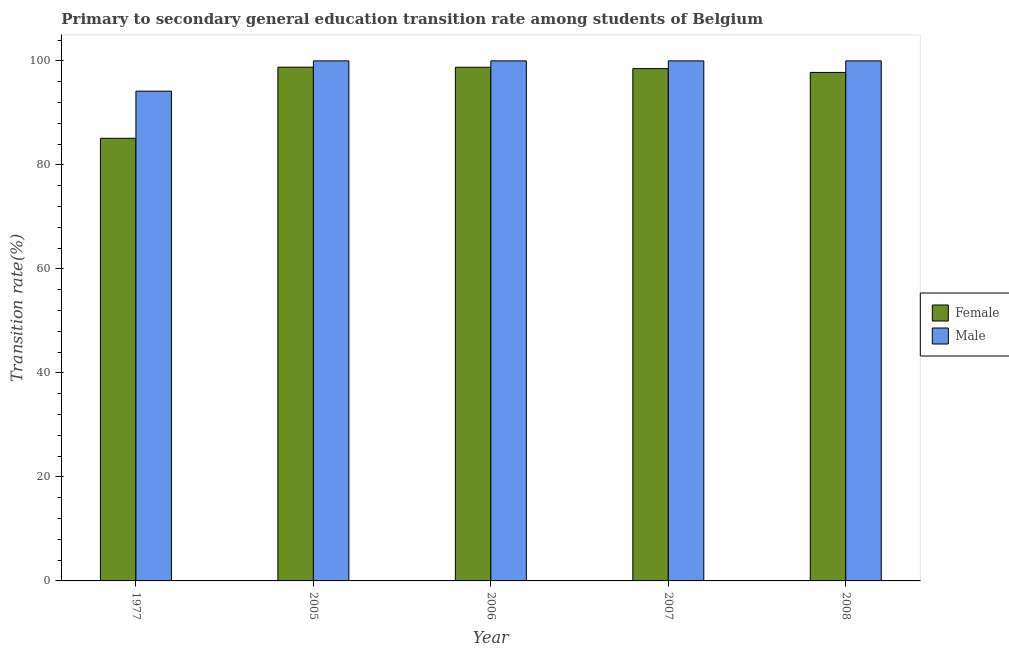How many different coloured bars are there?
Give a very brief answer. 2. Are the number of bars per tick equal to the number of legend labels?
Offer a very short reply. Yes. How many bars are there on the 3rd tick from the left?
Your answer should be compact. 2. In how many cases, is the number of bars for a given year not equal to the number of legend labels?
Give a very brief answer. 0. What is the transition rate among male students in 1977?
Offer a very short reply. 94.18. Across all years, what is the maximum transition rate among male students?
Keep it short and to the point. 100. Across all years, what is the minimum transition rate among male students?
Your answer should be very brief. 94.18. In which year was the transition rate among female students maximum?
Ensure brevity in your answer.  2005. What is the total transition rate among male students in the graph?
Offer a very short reply. 494.18. What is the difference between the transition rate among female students in 2005 and that in 2007?
Keep it short and to the point. 0.27. What is the difference between the transition rate among male students in 2008 and the transition rate among female students in 1977?
Provide a succinct answer. 5.82. What is the average transition rate among female students per year?
Give a very brief answer. 95.79. In the year 2006, what is the difference between the transition rate among male students and transition rate among female students?
Your response must be concise. 0. What is the ratio of the transition rate among female students in 2007 to that in 2008?
Keep it short and to the point. 1.01. Is the transition rate among female students in 2006 less than that in 2008?
Ensure brevity in your answer.  No. What is the difference between the highest and the second highest transition rate among female students?
Provide a succinct answer. 0.02. What is the difference between the highest and the lowest transition rate among male students?
Offer a very short reply. 5.82. In how many years, is the transition rate among female students greater than the average transition rate among female students taken over all years?
Your answer should be very brief. 4. How many bars are there?
Offer a very short reply. 10. How many years are there in the graph?
Provide a succinct answer. 5. Does the graph contain grids?
Offer a very short reply. No. How many legend labels are there?
Your response must be concise. 2. How are the legend labels stacked?
Provide a succinct answer. Vertical. What is the title of the graph?
Offer a terse response. Primary to secondary general education transition rate among students of Belgium. What is the label or title of the X-axis?
Provide a short and direct response. Year. What is the label or title of the Y-axis?
Your answer should be compact. Transition rate(%). What is the Transition rate(%) of Female in 1977?
Your answer should be very brief. 85.11. What is the Transition rate(%) of Male in 1977?
Provide a short and direct response. 94.18. What is the Transition rate(%) in Female in 2005?
Provide a succinct answer. 98.79. What is the Transition rate(%) of Female in 2006?
Your answer should be very brief. 98.77. What is the Transition rate(%) in Male in 2006?
Your answer should be compact. 100. What is the Transition rate(%) in Female in 2007?
Offer a very short reply. 98.52. What is the Transition rate(%) in Female in 2008?
Ensure brevity in your answer.  97.78. What is the Transition rate(%) in Male in 2008?
Your response must be concise. 100. Across all years, what is the maximum Transition rate(%) of Female?
Provide a short and direct response. 98.79. Across all years, what is the maximum Transition rate(%) in Male?
Provide a short and direct response. 100. Across all years, what is the minimum Transition rate(%) in Female?
Make the answer very short. 85.11. Across all years, what is the minimum Transition rate(%) in Male?
Offer a very short reply. 94.18. What is the total Transition rate(%) of Female in the graph?
Ensure brevity in your answer.  478.96. What is the total Transition rate(%) in Male in the graph?
Ensure brevity in your answer.  494.18. What is the difference between the Transition rate(%) in Female in 1977 and that in 2005?
Your response must be concise. -13.67. What is the difference between the Transition rate(%) in Male in 1977 and that in 2005?
Ensure brevity in your answer.  -5.82. What is the difference between the Transition rate(%) in Female in 1977 and that in 2006?
Your answer should be very brief. -13.65. What is the difference between the Transition rate(%) of Male in 1977 and that in 2006?
Offer a very short reply. -5.82. What is the difference between the Transition rate(%) in Female in 1977 and that in 2007?
Your answer should be compact. -13.4. What is the difference between the Transition rate(%) in Male in 1977 and that in 2007?
Offer a very short reply. -5.82. What is the difference between the Transition rate(%) of Female in 1977 and that in 2008?
Offer a very short reply. -12.66. What is the difference between the Transition rate(%) of Male in 1977 and that in 2008?
Your response must be concise. -5.82. What is the difference between the Transition rate(%) in Female in 2005 and that in 2006?
Provide a short and direct response. 0.02. What is the difference between the Transition rate(%) in Male in 2005 and that in 2006?
Your answer should be compact. 0. What is the difference between the Transition rate(%) of Female in 2005 and that in 2007?
Offer a very short reply. 0.27. What is the difference between the Transition rate(%) in Male in 2005 and that in 2007?
Provide a short and direct response. 0. What is the difference between the Transition rate(%) in Female in 2005 and that in 2008?
Your answer should be compact. 1.01. What is the difference between the Transition rate(%) of Male in 2005 and that in 2008?
Offer a terse response. 0. What is the difference between the Transition rate(%) of Female in 2006 and that in 2007?
Offer a very short reply. 0.25. What is the difference between the Transition rate(%) of Female in 2006 and that in 2008?
Keep it short and to the point. 0.99. What is the difference between the Transition rate(%) in Female in 2007 and that in 2008?
Offer a terse response. 0.74. What is the difference between the Transition rate(%) in Female in 1977 and the Transition rate(%) in Male in 2005?
Give a very brief answer. -14.89. What is the difference between the Transition rate(%) of Female in 1977 and the Transition rate(%) of Male in 2006?
Provide a short and direct response. -14.89. What is the difference between the Transition rate(%) in Female in 1977 and the Transition rate(%) in Male in 2007?
Make the answer very short. -14.89. What is the difference between the Transition rate(%) in Female in 1977 and the Transition rate(%) in Male in 2008?
Your response must be concise. -14.89. What is the difference between the Transition rate(%) in Female in 2005 and the Transition rate(%) in Male in 2006?
Make the answer very short. -1.21. What is the difference between the Transition rate(%) in Female in 2005 and the Transition rate(%) in Male in 2007?
Make the answer very short. -1.21. What is the difference between the Transition rate(%) in Female in 2005 and the Transition rate(%) in Male in 2008?
Provide a short and direct response. -1.21. What is the difference between the Transition rate(%) of Female in 2006 and the Transition rate(%) of Male in 2007?
Ensure brevity in your answer.  -1.23. What is the difference between the Transition rate(%) in Female in 2006 and the Transition rate(%) in Male in 2008?
Keep it short and to the point. -1.23. What is the difference between the Transition rate(%) of Female in 2007 and the Transition rate(%) of Male in 2008?
Offer a very short reply. -1.48. What is the average Transition rate(%) of Female per year?
Make the answer very short. 95.79. What is the average Transition rate(%) of Male per year?
Your answer should be very brief. 98.84. In the year 1977, what is the difference between the Transition rate(%) in Female and Transition rate(%) in Male?
Keep it short and to the point. -9.06. In the year 2005, what is the difference between the Transition rate(%) of Female and Transition rate(%) of Male?
Your answer should be compact. -1.21. In the year 2006, what is the difference between the Transition rate(%) of Female and Transition rate(%) of Male?
Your answer should be very brief. -1.23. In the year 2007, what is the difference between the Transition rate(%) in Female and Transition rate(%) in Male?
Give a very brief answer. -1.48. In the year 2008, what is the difference between the Transition rate(%) in Female and Transition rate(%) in Male?
Give a very brief answer. -2.22. What is the ratio of the Transition rate(%) of Female in 1977 to that in 2005?
Provide a short and direct response. 0.86. What is the ratio of the Transition rate(%) in Male in 1977 to that in 2005?
Offer a terse response. 0.94. What is the ratio of the Transition rate(%) of Female in 1977 to that in 2006?
Give a very brief answer. 0.86. What is the ratio of the Transition rate(%) of Male in 1977 to that in 2006?
Provide a short and direct response. 0.94. What is the ratio of the Transition rate(%) in Female in 1977 to that in 2007?
Provide a succinct answer. 0.86. What is the ratio of the Transition rate(%) of Male in 1977 to that in 2007?
Your response must be concise. 0.94. What is the ratio of the Transition rate(%) of Female in 1977 to that in 2008?
Your response must be concise. 0.87. What is the ratio of the Transition rate(%) of Male in 1977 to that in 2008?
Make the answer very short. 0.94. What is the ratio of the Transition rate(%) in Female in 2005 to that in 2006?
Your answer should be compact. 1. What is the ratio of the Transition rate(%) of Female in 2005 to that in 2007?
Offer a very short reply. 1. What is the ratio of the Transition rate(%) of Male in 2005 to that in 2007?
Ensure brevity in your answer.  1. What is the ratio of the Transition rate(%) in Female in 2005 to that in 2008?
Provide a short and direct response. 1.01. What is the ratio of the Transition rate(%) of Male in 2006 to that in 2007?
Your answer should be compact. 1. What is the ratio of the Transition rate(%) of Female in 2007 to that in 2008?
Your response must be concise. 1.01. What is the ratio of the Transition rate(%) of Male in 2007 to that in 2008?
Your answer should be very brief. 1. What is the difference between the highest and the second highest Transition rate(%) of Female?
Provide a short and direct response. 0.02. What is the difference between the highest and the lowest Transition rate(%) in Female?
Provide a succinct answer. 13.67. What is the difference between the highest and the lowest Transition rate(%) of Male?
Offer a very short reply. 5.82. 